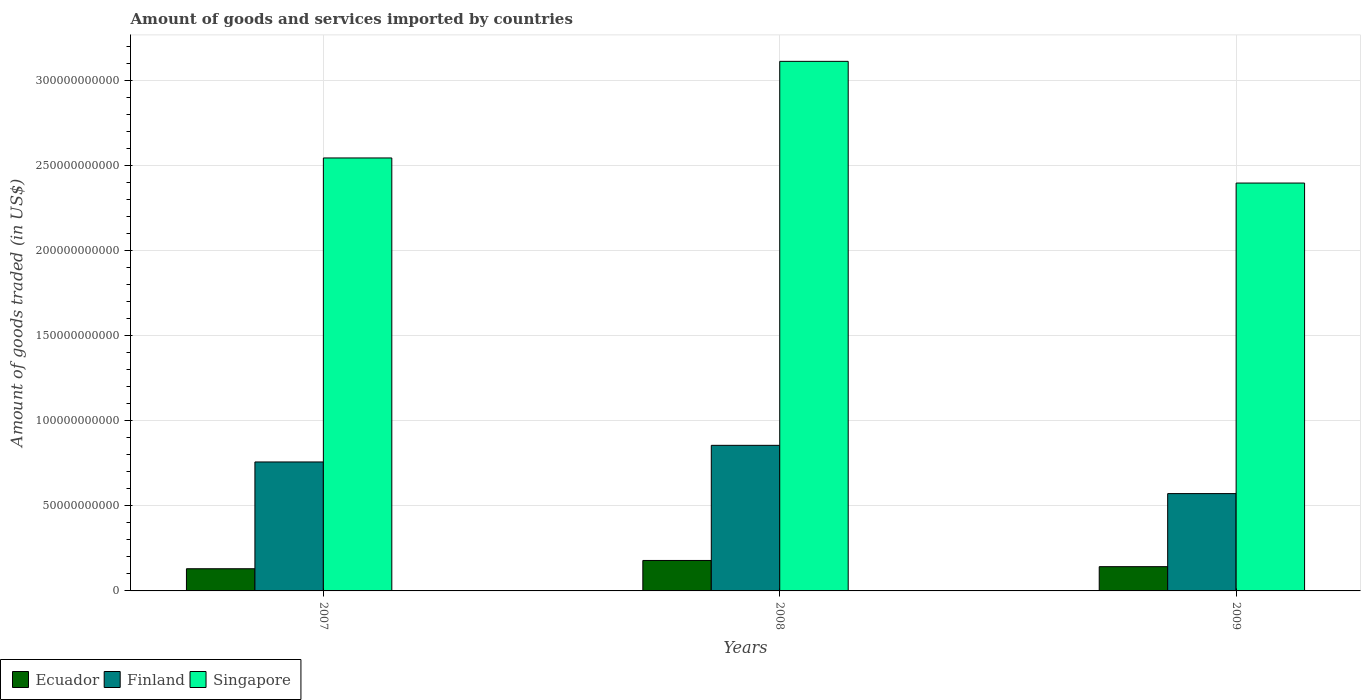How many different coloured bars are there?
Your response must be concise. 3. How many bars are there on the 1st tick from the left?
Ensure brevity in your answer.  3. What is the label of the 1st group of bars from the left?
Make the answer very short. 2007. What is the total amount of goods and services imported in Singapore in 2007?
Give a very brief answer. 2.55e+11. Across all years, what is the maximum total amount of goods and services imported in Finland?
Your answer should be very brief. 8.56e+1. Across all years, what is the minimum total amount of goods and services imported in Ecuador?
Offer a terse response. 1.30e+1. In which year was the total amount of goods and services imported in Ecuador maximum?
Your answer should be very brief. 2008. What is the total total amount of goods and services imported in Singapore in the graph?
Make the answer very short. 8.06e+11. What is the difference between the total amount of goods and services imported in Singapore in 2007 and that in 2009?
Offer a very short reply. 1.48e+1. What is the difference between the total amount of goods and services imported in Ecuador in 2007 and the total amount of goods and services imported in Singapore in 2009?
Ensure brevity in your answer.  -2.27e+11. What is the average total amount of goods and services imported in Finland per year?
Ensure brevity in your answer.  7.29e+1. In the year 2008, what is the difference between the total amount of goods and services imported in Ecuador and total amount of goods and services imported in Singapore?
Your answer should be compact. -2.93e+11. What is the ratio of the total amount of goods and services imported in Singapore in 2007 to that in 2008?
Keep it short and to the point. 0.82. Is the total amount of goods and services imported in Finland in 2007 less than that in 2009?
Provide a succinct answer. No. What is the difference between the highest and the second highest total amount of goods and services imported in Finland?
Keep it short and to the point. 9.78e+09. What is the difference between the highest and the lowest total amount of goods and services imported in Ecuador?
Make the answer very short. 4.86e+09. Is the sum of the total amount of goods and services imported in Finland in 2007 and 2008 greater than the maximum total amount of goods and services imported in Ecuador across all years?
Your response must be concise. Yes. What does the 3rd bar from the left in 2007 represents?
Offer a terse response. Singapore. What does the 3rd bar from the right in 2009 represents?
Offer a very short reply. Ecuador. Is it the case that in every year, the sum of the total amount of goods and services imported in Ecuador and total amount of goods and services imported in Singapore is greater than the total amount of goods and services imported in Finland?
Make the answer very short. Yes. How many years are there in the graph?
Keep it short and to the point. 3. Does the graph contain any zero values?
Your answer should be compact. No. Where does the legend appear in the graph?
Provide a succinct answer. Bottom left. How many legend labels are there?
Provide a succinct answer. 3. What is the title of the graph?
Your answer should be compact. Amount of goods and services imported by countries. What is the label or title of the Y-axis?
Provide a succinct answer. Amount of goods traded (in US$). What is the Amount of goods traded (in US$) of Ecuador in 2007?
Your response must be concise. 1.30e+1. What is the Amount of goods traded (in US$) in Finland in 2007?
Offer a very short reply. 7.58e+1. What is the Amount of goods traded (in US$) in Singapore in 2007?
Provide a short and direct response. 2.55e+11. What is the Amount of goods traded (in US$) of Ecuador in 2008?
Your response must be concise. 1.79e+1. What is the Amount of goods traded (in US$) in Finland in 2008?
Provide a succinct answer. 8.56e+1. What is the Amount of goods traded (in US$) of Singapore in 2008?
Give a very brief answer. 3.11e+11. What is the Amount of goods traded (in US$) in Ecuador in 2009?
Your response must be concise. 1.43e+1. What is the Amount of goods traded (in US$) in Finland in 2009?
Your answer should be very brief. 5.72e+1. What is the Amount of goods traded (in US$) in Singapore in 2009?
Your response must be concise. 2.40e+11. Across all years, what is the maximum Amount of goods traded (in US$) in Ecuador?
Ensure brevity in your answer.  1.79e+1. Across all years, what is the maximum Amount of goods traded (in US$) in Finland?
Keep it short and to the point. 8.56e+1. Across all years, what is the maximum Amount of goods traded (in US$) in Singapore?
Ensure brevity in your answer.  3.11e+11. Across all years, what is the minimum Amount of goods traded (in US$) in Ecuador?
Your response must be concise. 1.30e+1. Across all years, what is the minimum Amount of goods traded (in US$) in Finland?
Your response must be concise. 5.72e+1. Across all years, what is the minimum Amount of goods traded (in US$) in Singapore?
Ensure brevity in your answer.  2.40e+11. What is the total Amount of goods traded (in US$) of Ecuador in the graph?
Provide a short and direct response. 4.52e+1. What is the total Amount of goods traded (in US$) of Finland in the graph?
Your response must be concise. 2.19e+11. What is the total Amount of goods traded (in US$) in Singapore in the graph?
Offer a terse response. 8.06e+11. What is the difference between the Amount of goods traded (in US$) in Ecuador in 2007 and that in 2008?
Ensure brevity in your answer.  -4.86e+09. What is the difference between the Amount of goods traded (in US$) of Finland in 2007 and that in 2008?
Give a very brief answer. -9.78e+09. What is the difference between the Amount of goods traded (in US$) in Singapore in 2007 and that in 2008?
Your answer should be very brief. -5.68e+1. What is the difference between the Amount of goods traded (in US$) of Ecuador in 2007 and that in 2009?
Offer a very short reply. -1.22e+09. What is the difference between the Amount of goods traded (in US$) in Finland in 2007 and that in 2009?
Ensure brevity in your answer.  1.86e+1. What is the difference between the Amount of goods traded (in US$) of Singapore in 2007 and that in 2009?
Make the answer very short. 1.48e+1. What is the difference between the Amount of goods traded (in US$) of Ecuador in 2008 and that in 2009?
Offer a terse response. 3.64e+09. What is the difference between the Amount of goods traded (in US$) in Finland in 2008 and that in 2009?
Make the answer very short. 2.84e+1. What is the difference between the Amount of goods traded (in US$) of Singapore in 2008 and that in 2009?
Keep it short and to the point. 7.15e+1. What is the difference between the Amount of goods traded (in US$) of Ecuador in 2007 and the Amount of goods traded (in US$) of Finland in 2008?
Ensure brevity in your answer.  -7.25e+1. What is the difference between the Amount of goods traded (in US$) of Ecuador in 2007 and the Amount of goods traded (in US$) of Singapore in 2008?
Provide a succinct answer. -2.98e+11. What is the difference between the Amount of goods traded (in US$) in Finland in 2007 and the Amount of goods traded (in US$) in Singapore in 2008?
Provide a succinct answer. -2.36e+11. What is the difference between the Amount of goods traded (in US$) in Ecuador in 2007 and the Amount of goods traded (in US$) in Finland in 2009?
Provide a succinct answer. -4.42e+1. What is the difference between the Amount of goods traded (in US$) in Ecuador in 2007 and the Amount of goods traded (in US$) in Singapore in 2009?
Give a very brief answer. -2.27e+11. What is the difference between the Amount of goods traded (in US$) of Finland in 2007 and the Amount of goods traded (in US$) of Singapore in 2009?
Provide a short and direct response. -1.64e+11. What is the difference between the Amount of goods traded (in US$) in Ecuador in 2008 and the Amount of goods traded (in US$) in Finland in 2009?
Keep it short and to the point. -3.93e+1. What is the difference between the Amount of goods traded (in US$) of Ecuador in 2008 and the Amount of goods traded (in US$) of Singapore in 2009?
Provide a succinct answer. -2.22e+11. What is the difference between the Amount of goods traded (in US$) in Finland in 2008 and the Amount of goods traded (in US$) in Singapore in 2009?
Offer a very short reply. -1.54e+11. What is the average Amount of goods traded (in US$) of Ecuador per year?
Offer a terse response. 1.51e+1. What is the average Amount of goods traded (in US$) in Finland per year?
Provide a succinct answer. 7.29e+1. What is the average Amount of goods traded (in US$) in Singapore per year?
Ensure brevity in your answer.  2.69e+11. In the year 2007, what is the difference between the Amount of goods traded (in US$) in Ecuador and Amount of goods traded (in US$) in Finland?
Make the answer very short. -6.28e+1. In the year 2007, what is the difference between the Amount of goods traded (in US$) of Ecuador and Amount of goods traded (in US$) of Singapore?
Provide a succinct answer. -2.41e+11. In the year 2007, what is the difference between the Amount of goods traded (in US$) in Finland and Amount of goods traded (in US$) in Singapore?
Provide a succinct answer. -1.79e+11. In the year 2008, what is the difference between the Amount of goods traded (in US$) of Ecuador and Amount of goods traded (in US$) of Finland?
Keep it short and to the point. -6.77e+1. In the year 2008, what is the difference between the Amount of goods traded (in US$) in Ecuador and Amount of goods traded (in US$) in Singapore?
Keep it short and to the point. -2.93e+11. In the year 2008, what is the difference between the Amount of goods traded (in US$) in Finland and Amount of goods traded (in US$) in Singapore?
Your answer should be very brief. -2.26e+11. In the year 2009, what is the difference between the Amount of goods traded (in US$) of Ecuador and Amount of goods traded (in US$) of Finland?
Give a very brief answer. -4.29e+1. In the year 2009, what is the difference between the Amount of goods traded (in US$) of Ecuador and Amount of goods traded (in US$) of Singapore?
Ensure brevity in your answer.  -2.26e+11. In the year 2009, what is the difference between the Amount of goods traded (in US$) of Finland and Amount of goods traded (in US$) of Singapore?
Offer a very short reply. -1.83e+11. What is the ratio of the Amount of goods traded (in US$) in Ecuador in 2007 to that in 2008?
Your answer should be compact. 0.73. What is the ratio of the Amount of goods traded (in US$) of Finland in 2007 to that in 2008?
Provide a short and direct response. 0.89. What is the ratio of the Amount of goods traded (in US$) of Singapore in 2007 to that in 2008?
Offer a terse response. 0.82. What is the ratio of the Amount of goods traded (in US$) in Ecuador in 2007 to that in 2009?
Your response must be concise. 0.91. What is the ratio of the Amount of goods traded (in US$) of Finland in 2007 to that in 2009?
Your answer should be very brief. 1.33. What is the ratio of the Amount of goods traded (in US$) of Singapore in 2007 to that in 2009?
Give a very brief answer. 1.06. What is the ratio of the Amount of goods traded (in US$) in Ecuador in 2008 to that in 2009?
Your answer should be compact. 1.26. What is the ratio of the Amount of goods traded (in US$) in Finland in 2008 to that in 2009?
Your response must be concise. 1.5. What is the ratio of the Amount of goods traded (in US$) in Singapore in 2008 to that in 2009?
Provide a short and direct response. 1.3. What is the difference between the highest and the second highest Amount of goods traded (in US$) in Ecuador?
Ensure brevity in your answer.  3.64e+09. What is the difference between the highest and the second highest Amount of goods traded (in US$) in Finland?
Give a very brief answer. 9.78e+09. What is the difference between the highest and the second highest Amount of goods traded (in US$) of Singapore?
Make the answer very short. 5.68e+1. What is the difference between the highest and the lowest Amount of goods traded (in US$) of Ecuador?
Ensure brevity in your answer.  4.86e+09. What is the difference between the highest and the lowest Amount of goods traded (in US$) of Finland?
Give a very brief answer. 2.84e+1. What is the difference between the highest and the lowest Amount of goods traded (in US$) in Singapore?
Your response must be concise. 7.15e+1. 